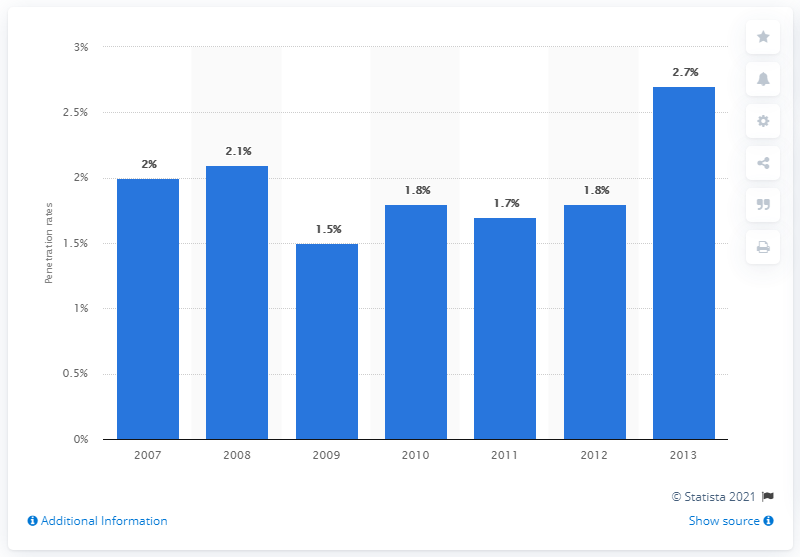Outline some significant characteristics in this image. In 2007, the rate of households owning reptiles was approximately 2%. 